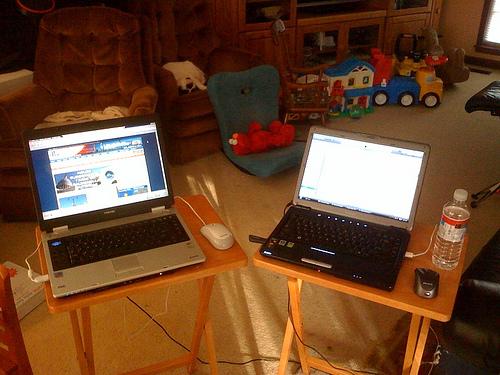Are the laptops turned on?
Quick response, please. Yes. What drink is on the table?
Write a very short answer. Water. How many laptops are in the photo?
Write a very short answer. 2. 